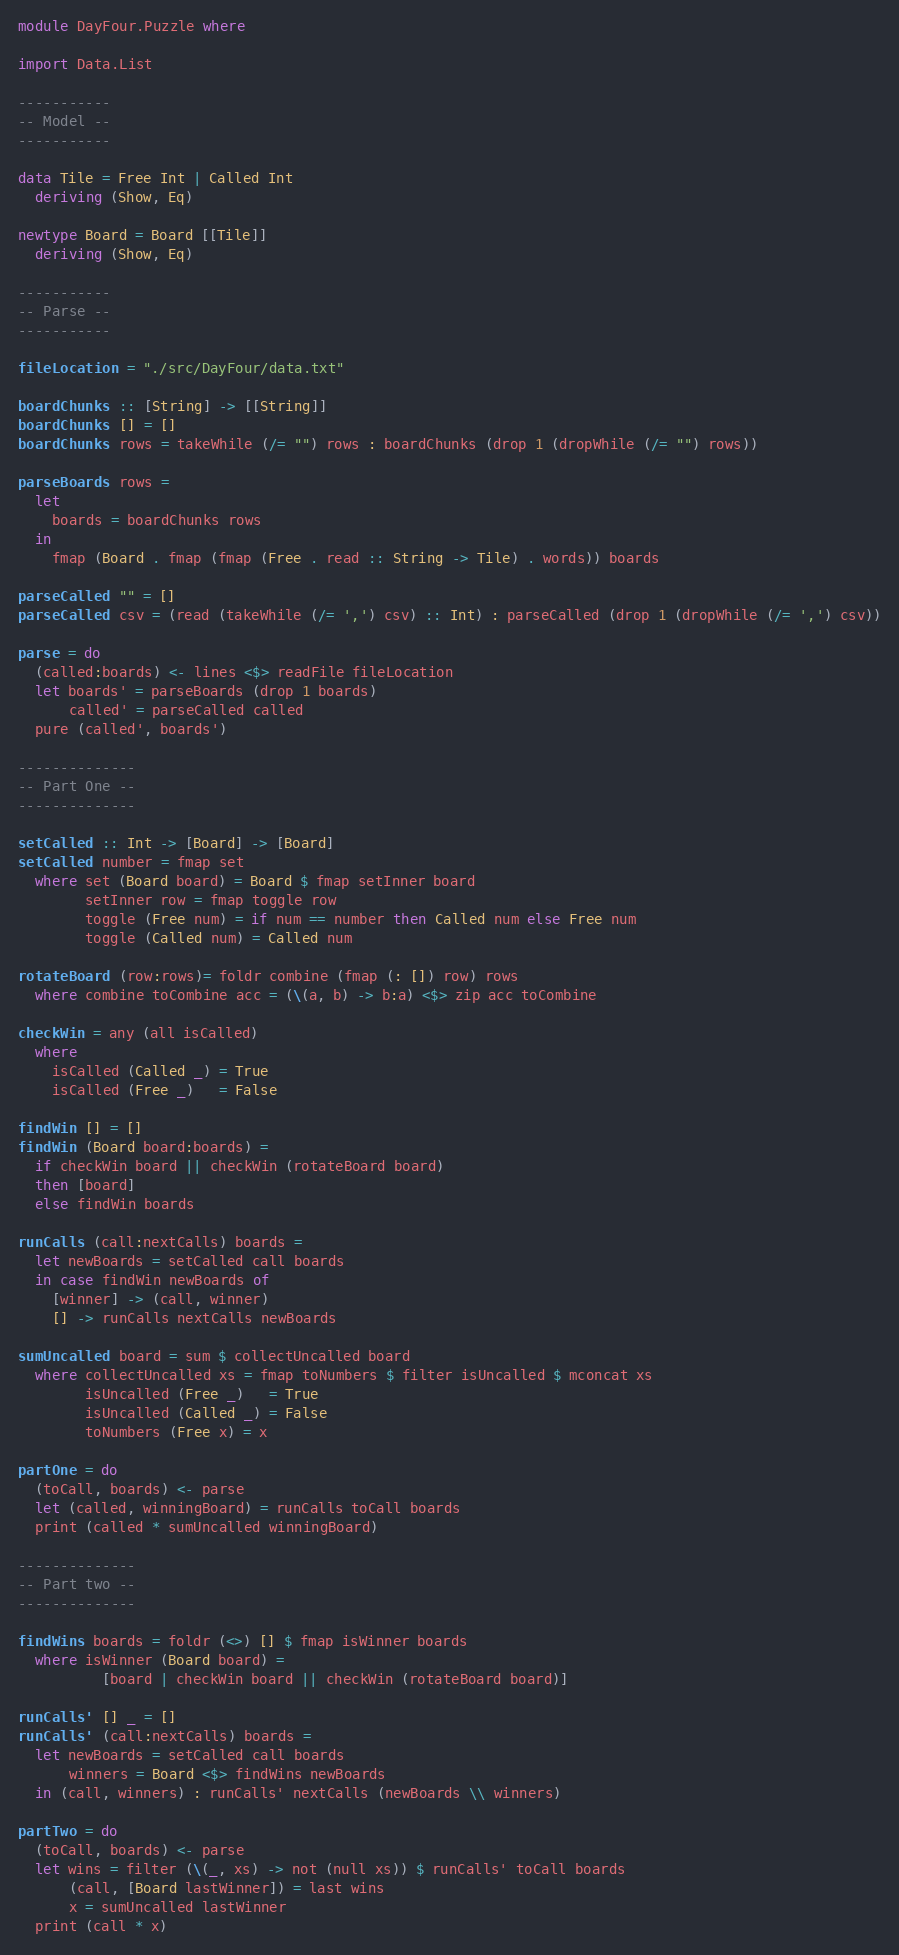<code> <loc_0><loc_0><loc_500><loc_500><_Haskell_>module DayFour.Puzzle where

import Data.List

-----------
-- Model --
-----------

data Tile = Free Int | Called Int
  deriving (Show, Eq)

newtype Board = Board [[Tile]]
  deriving (Show, Eq)

-----------
-- Parse --
-----------

fileLocation = "./src/DayFour/data.txt"

boardChunks :: [String] -> [[String]]
boardChunks [] = []
boardChunks rows = takeWhile (/= "") rows : boardChunks (drop 1 (dropWhile (/= "") rows))

parseBoards rows =
  let
    boards = boardChunks rows
  in
    fmap (Board . fmap (fmap (Free . read :: String -> Tile) . words)) boards

parseCalled "" = []
parseCalled csv = (read (takeWhile (/= ',') csv) :: Int) : parseCalled (drop 1 (dropWhile (/= ',') csv))

parse = do
  (called:boards) <- lines <$> readFile fileLocation
  let boards' = parseBoards (drop 1 boards)
      called' = parseCalled called
  pure (called', boards')

--------------
-- Part One --
--------------

setCalled :: Int -> [Board] -> [Board]
setCalled number = fmap set
  where set (Board board) = Board $ fmap setInner board
        setInner row = fmap toggle row
        toggle (Free num) = if num == number then Called num else Free num
        toggle (Called num) = Called num

rotateBoard (row:rows)= foldr combine (fmap (: []) row) rows
  where combine toCombine acc = (\(a, b) -> b:a) <$> zip acc toCombine

checkWin = any (all isCalled)
  where
    isCalled (Called _) = True
    isCalled (Free _)   = False

findWin [] = []
findWin (Board board:boards) =
  if checkWin board || checkWin (rotateBoard board)
  then [board]
  else findWin boards

runCalls (call:nextCalls) boards =
  let newBoards = setCalled call boards
  in case findWin newBoards of
    [winner] -> (call, winner)
    [] -> runCalls nextCalls newBoards

sumUncalled board = sum $ collectUncalled board
  where collectUncalled xs = fmap toNumbers $ filter isUncalled $ mconcat xs
        isUncalled (Free _)   = True
        isUncalled (Called _) = False
        toNumbers (Free x) = x

partOne = do
  (toCall, boards) <- parse
  let (called, winningBoard) = runCalls toCall boards
  print (called * sumUncalled winningBoard)

--------------
-- Part two --
--------------

findWins boards = foldr (<>) [] $ fmap isWinner boards
  where isWinner (Board board) =
          [board | checkWin board || checkWin (rotateBoard board)]

runCalls' [] _ = []
runCalls' (call:nextCalls) boards =
  let newBoards = setCalled call boards
      winners = Board <$> findWins newBoards
  in (call, winners) : runCalls' nextCalls (newBoards \\ winners)

partTwo = do
  (toCall, boards) <- parse
  let wins = filter (\(_, xs) -> not (null xs)) $ runCalls' toCall boards
      (call, [Board lastWinner]) = last wins
      x = sumUncalled lastWinner
  print (call * x)
</code> 